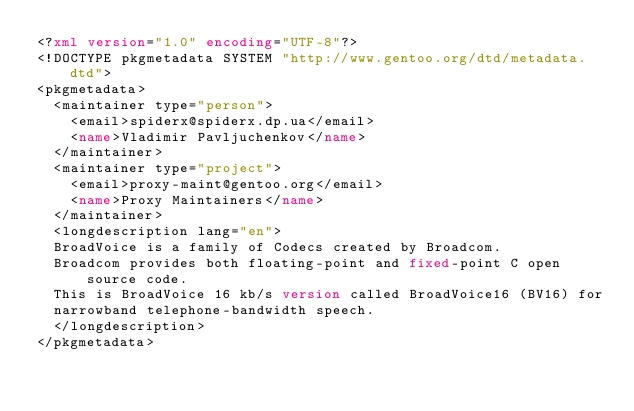<code> <loc_0><loc_0><loc_500><loc_500><_XML_><?xml version="1.0" encoding="UTF-8"?>
<!DOCTYPE pkgmetadata SYSTEM "http://www.gentoo.org/dtd/metadata.dtd">
<pkgmetadata>
	<maintainer type="person">
		<email>spiderx@spiderx.dp.ua</email>
		<name>Vladimir Pavljuchenkov</name>
	</maintainer>
	<maintainer type="project">
		<email>proxy-maint@gentoo.org</email>
		<name>Proxy Maintainers</name>
	</maintainer>
	<longdescription lang="en">
	BroadVoice is a family of Codecs created by Broadcom.
	Broadcom provides both floating-point and fixed-point C open source code.
	This is BroadVoice 16 kb/s version called BroadVoice16 (BV16) for
	narrowband telephone-bandwidth speech.
	</longdescription>
</pkgmetadata>
</code> 